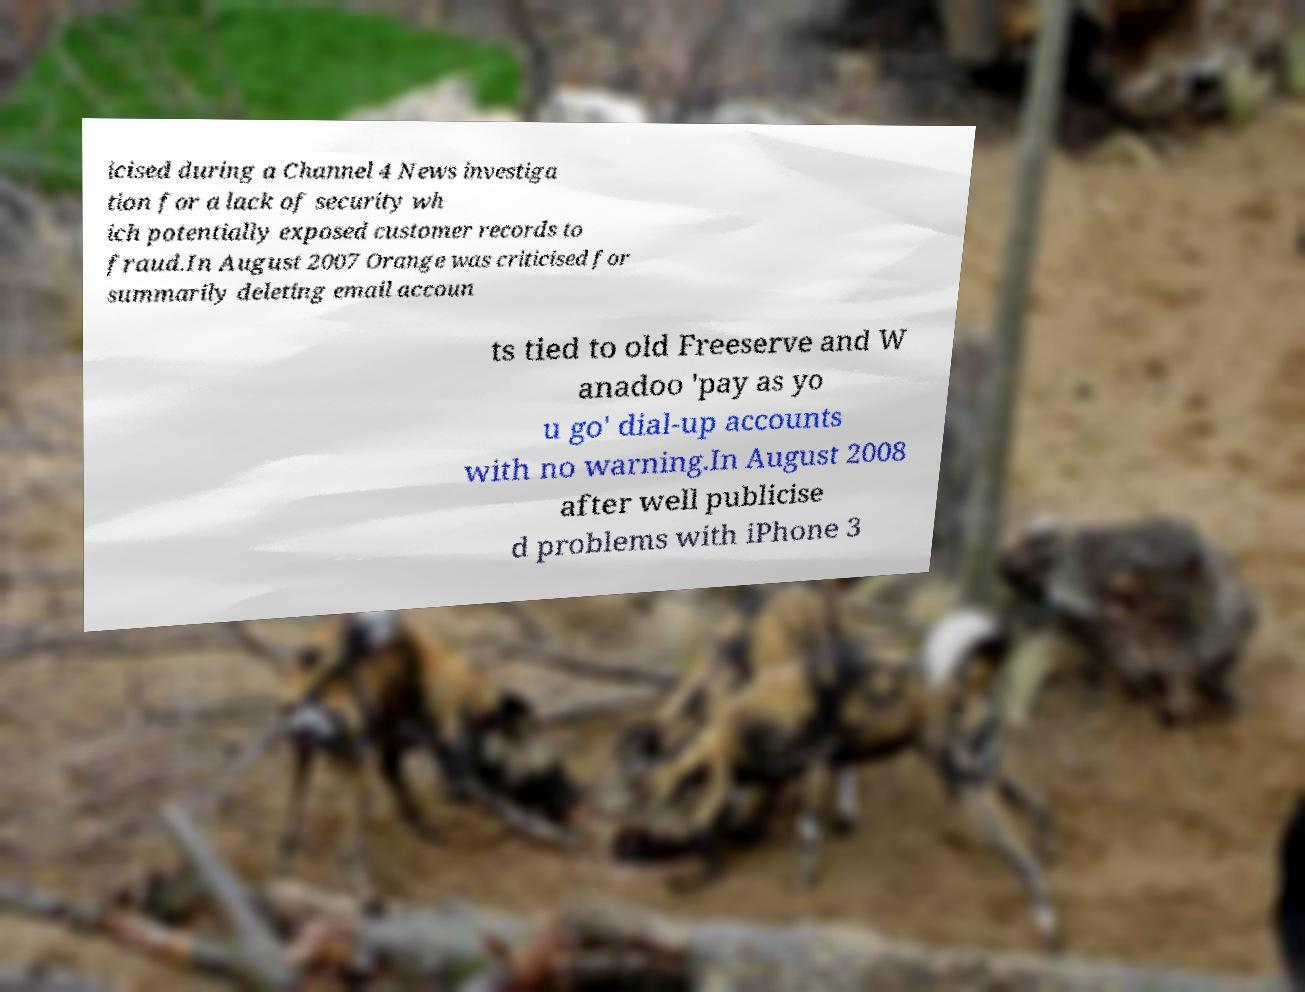Could you extract and type out the text from this image? icised during a Channel 4 News investiga tion for a lack of security wh ich potentially exposed customer records to fraud.In August 2007 Orange was criticised for summarily deleting email accoun ts tied to old Freeserve and W anadoo 'pay as yo u go' dial-up accounts with no warning.In August 2008 after well publicise d problems with iPhone 3 